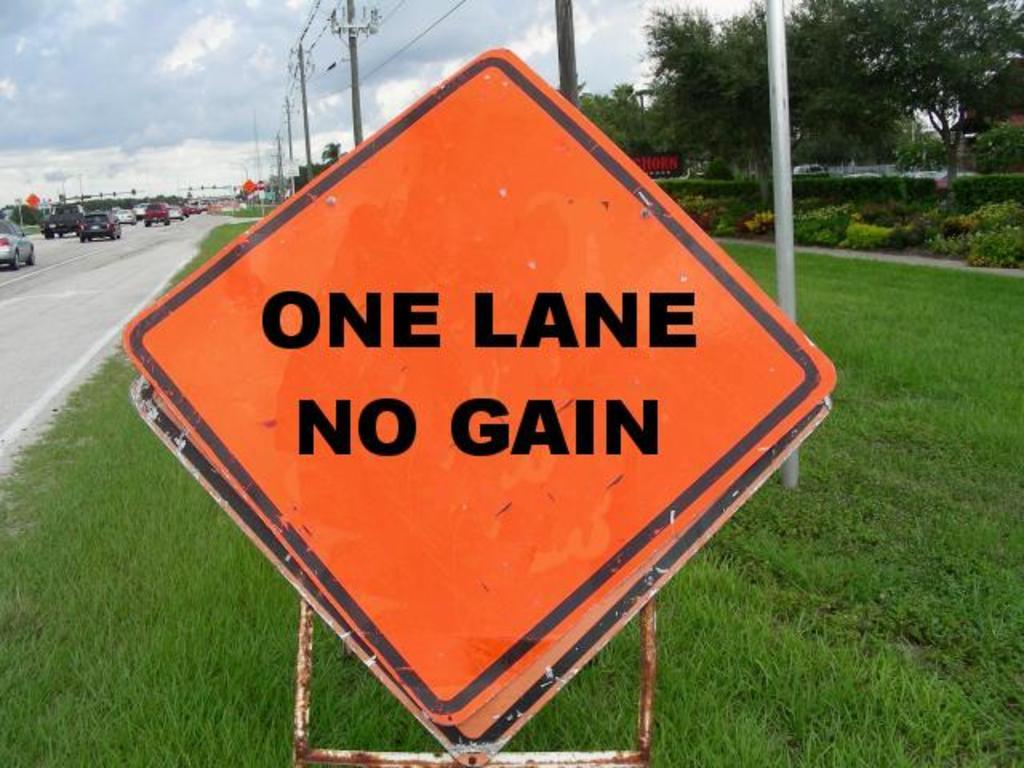<image>
Present a compact description of the photo's key features. Orange sign which says that ONE LANE NO GAIN. 